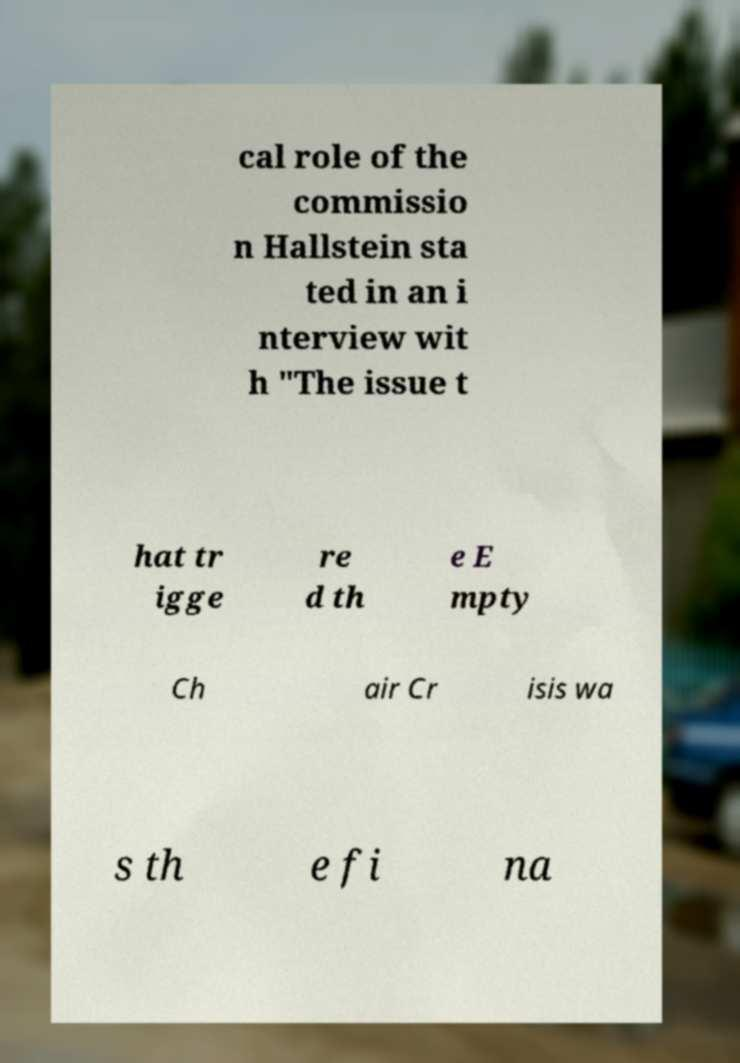Could you assist in decoding the text presented in this image and type it out clearly? cal role of the commissio n Hallstein sta ted in an i nterview wit h "The issue t hat tr igge re d th e E mpty Ch air Cr isis wa s th e fi na 